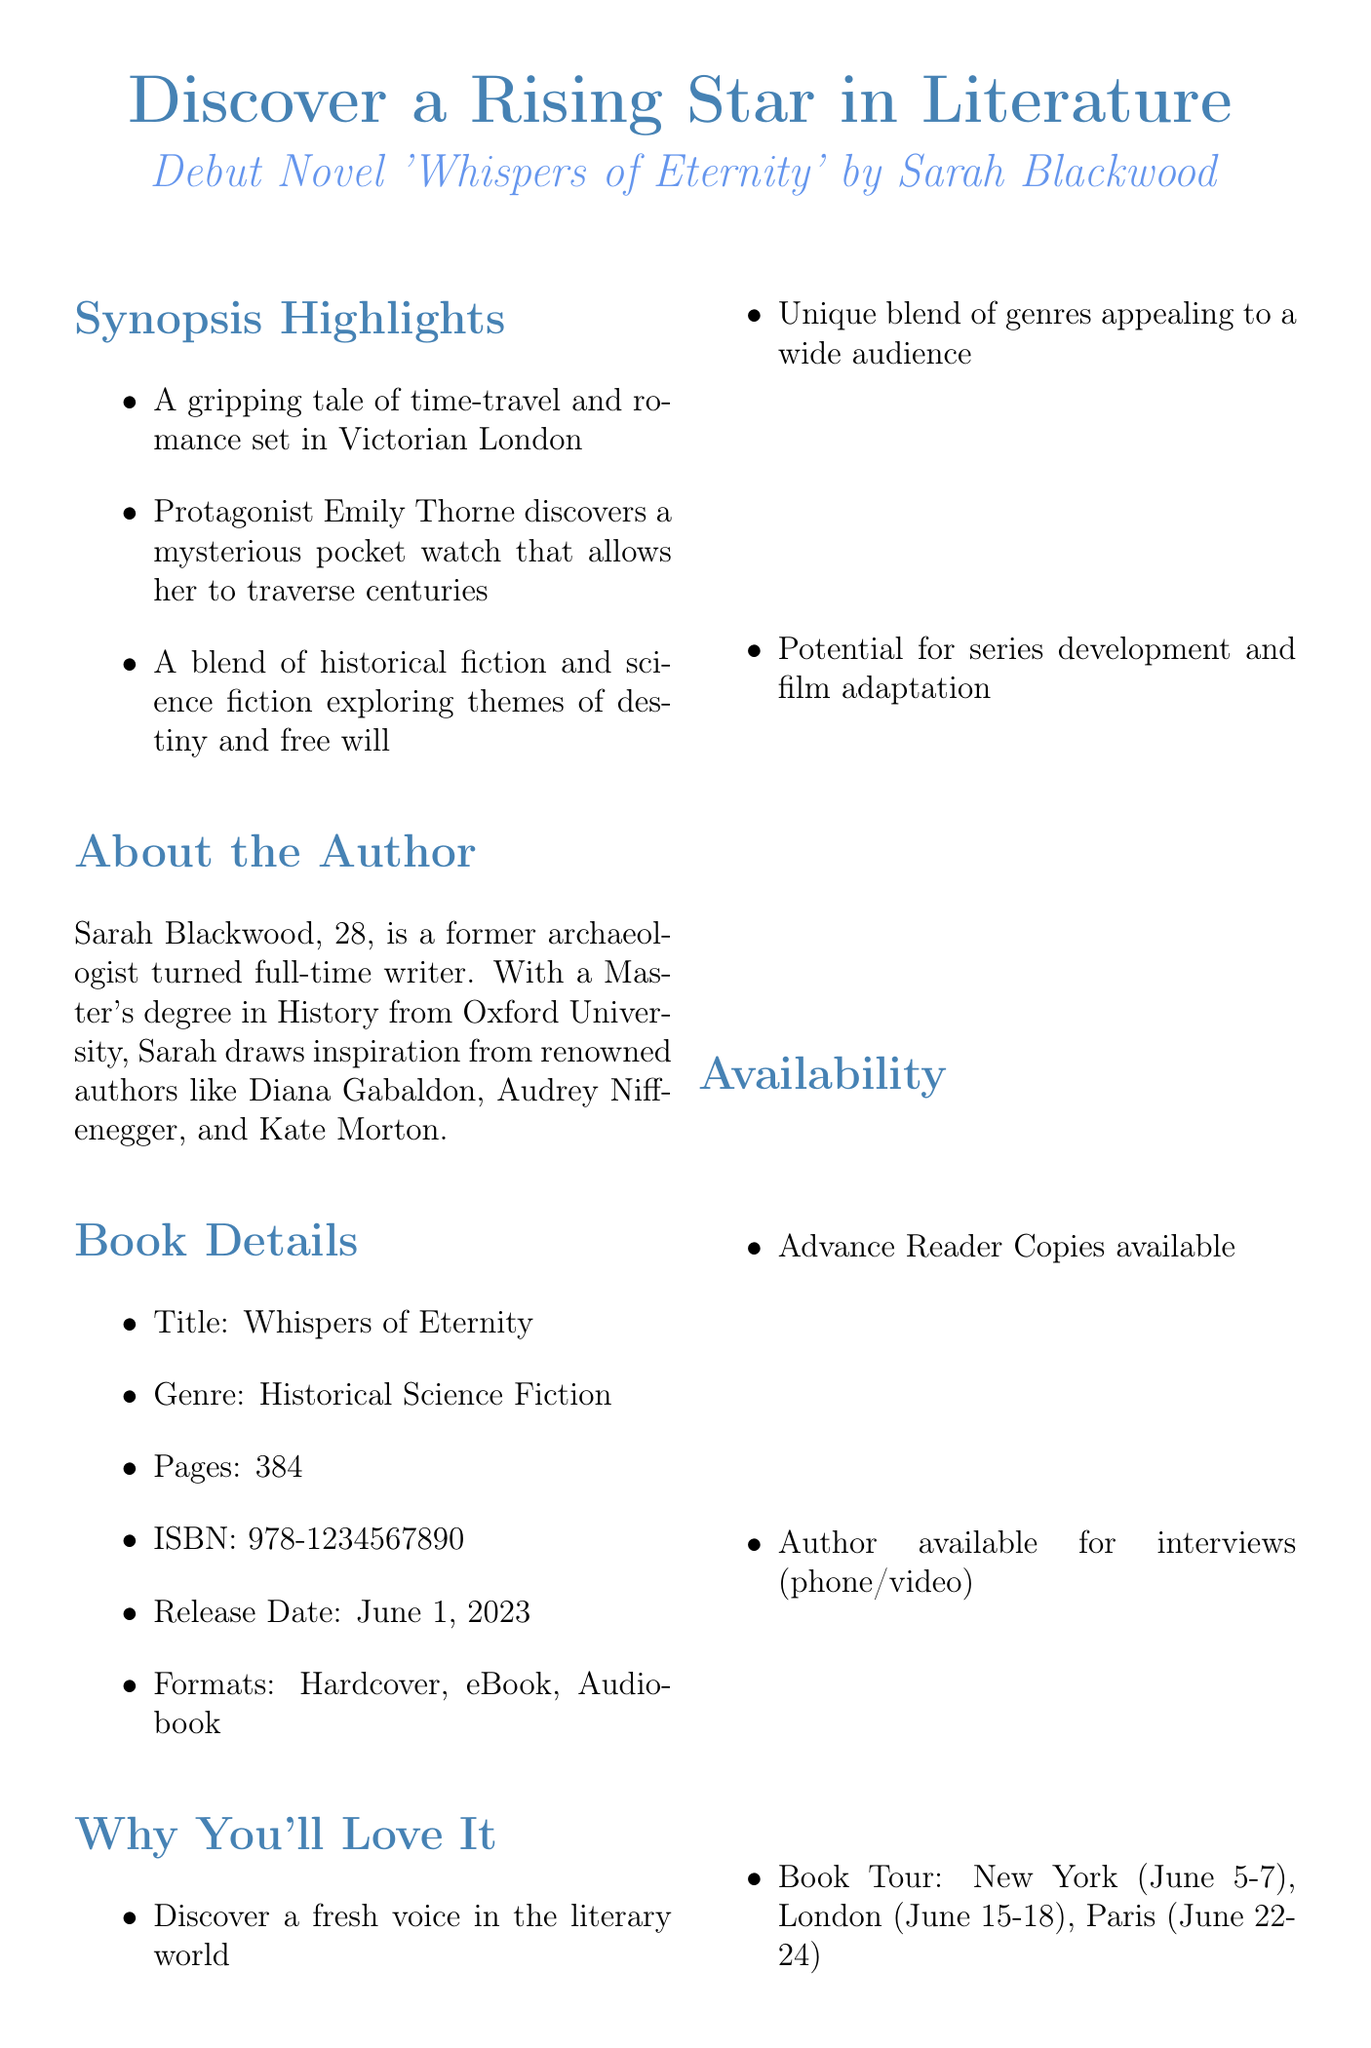What is the title of the debut novel? The title of the debut novel is presented in the document as "Whispers of Eternity."
Answer: Whispers of Eternity Who is the author of the novel? The document specifies Sarah Blackwood as the author of the novel.
Answer: Sarah Blackwood What is the release date of the novel? The release date mentioned in the document is June 1, 2023.
Answer: June 1, 2023 What genre does the book belong to? The document indicates that the genre of the book is Historical Science Fiction.
Answer: Historical Science Fiction How many pages does the novel have? The document states that the novel has a total of 384 pages.
Answer: 384 What university did the author attend for her Master's degree? According to the document, Sarah Blackwood obtained her Master's degree from Oxford University.
Answer: Oxford University What are the formats available for the book? The document lists the formats as Hardcover, eBook, and Audiobook.
Answer: Hardcover, eBook, Audiobook What is the contact person's name at the publishing company? The document mentions Jennifer Lopez as the contact person at Horizon Press.
Answer: Jennifer Lopez What opportunity does the reviewer have by covering this book? The document highlights the opportunity to discover a fresh voice in the literary world.
Answer: Discover a fresh voice in the literary world 